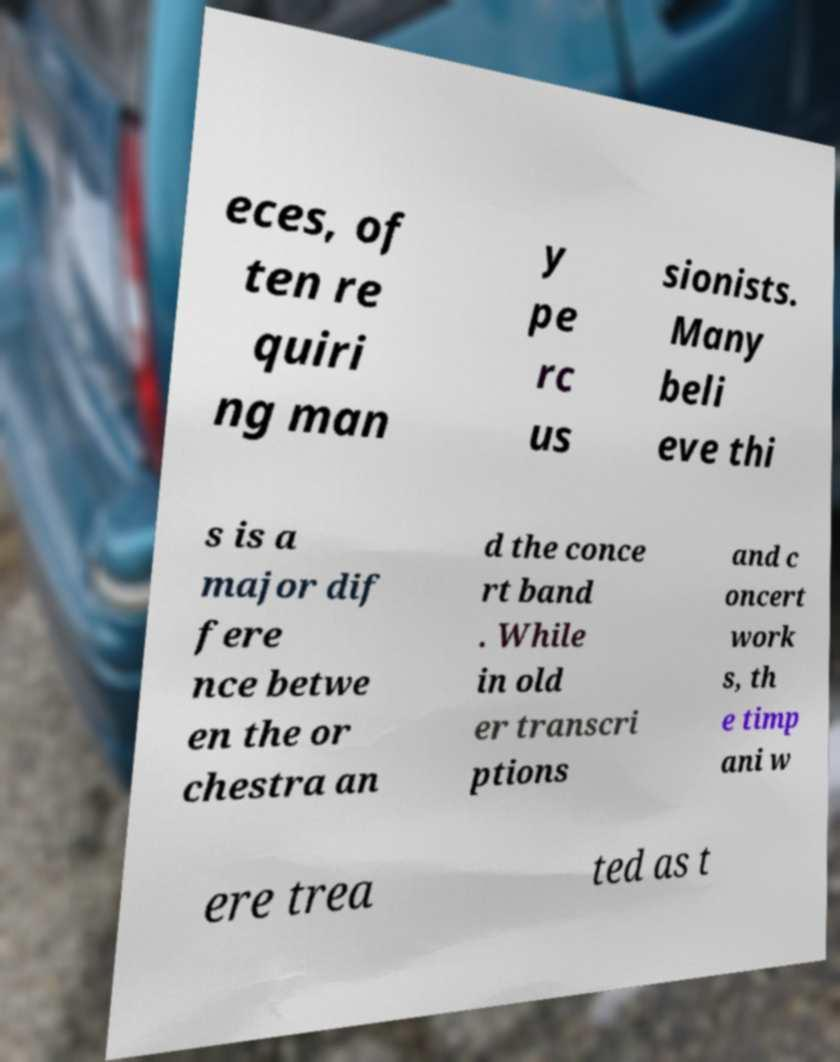What messages or text are displayed in this image? I need them in a readable, typed format. eces, of ten re quiri ng man y pe rc us sionists. Many beli eve thi s is a major dif fere nce betwe en the or chestra an d the conce rt band . While in old er transcri ptions and c oncert work s, th e timp ani w ere trea ted as t 